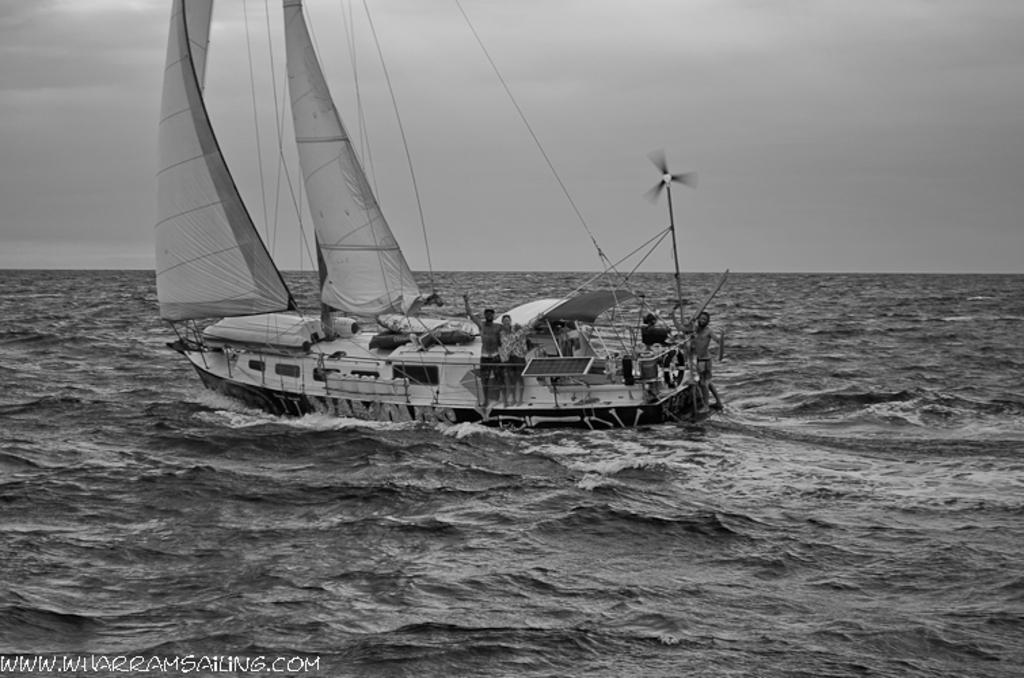What is the main subject of the image? The main subject of the image is a ship. Where is the ship located? The ship is on the water. What can be seen on the ship? There are people in the ship. What objects are visible in the image besides the ship? There are poles and flags in the image. What type of flower is growing on the ship in the image? There is no flower growing on the ship in the image. How many dimes can be seen on the ship in the image? There are no dimes present in the image. 